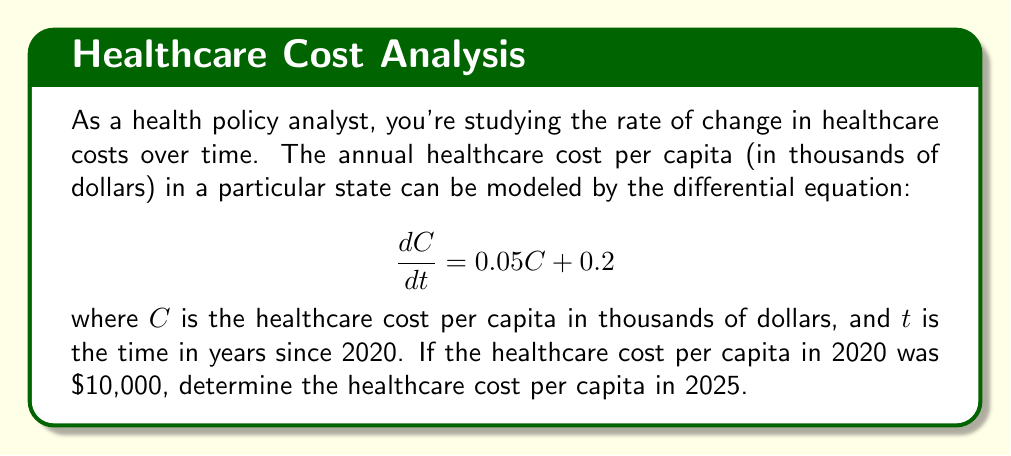Solve this math problem. To solve this problem, we need to follow these steps:

1) First, we recognize this as a first-order linear differential equation in the form:

   $$\frac{dC}{dt} = aC + b$$

   where $a = 0.05$ and $b = 0.2$

2) The general solution for this type of equation is:

   $$C(t) = Ce^{at} - \frac{b}{a}$$

   where $C$ is a constant we need to determine.

3) Substituting our values:

   $$C(t) = Ce^{0.05t} - \frac{0.2}{0.05} = Ce^{0.05t} - 4$$

4) Now, we use the initial condition. At $t=0$ (2020), $C = 10$:

   $$10 = Ce^{0.05(0)} - 4$$
   $$14 = C$$

5) So our particular solution is:

   $$C(t) = 14e^{0.05t} - 4$$

6) To find the cost in 2025, we calculate $C(5)$ since 2025 is 5 years after 2020:

   $$C(5) = 14e^{0.05(5)} - 4$$
   $$= 14e^{0.25} - 4$$
   $$\approx 14(1.2840) - 4$$
   $$\approx 13.976$$

7) Remember, this is in thousands of dollars, so we need to multiply by 1000.
Answer: The healthcare cost per capita in 2025 will be approximately $13,976. 